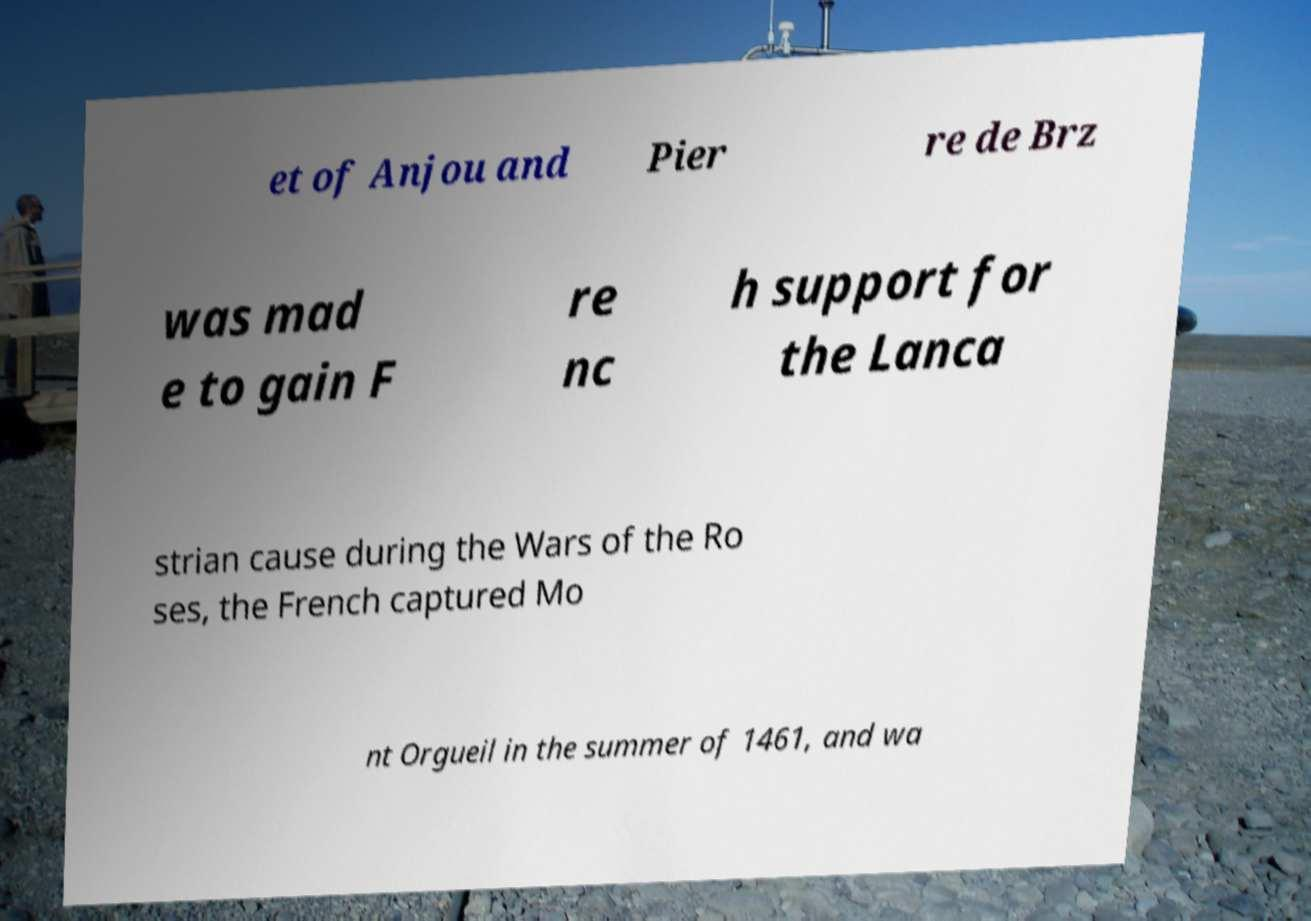What messages or text are displayed in this image? I need them in a readable, typed format. et of Anjou and Pier re de Brz was mad e to gain F re nc h support for the Lanca strian cause during the Wars of the Ro ses, the French captured Mo nt Orgueil in the summer of 1461, and wa 